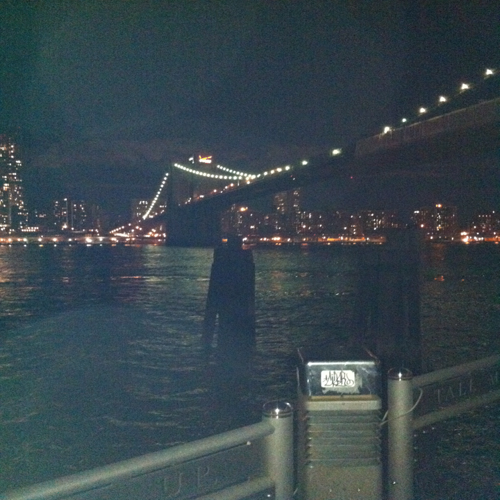What mood does this image evoke, and how does it achieve that? The image evokes a mood of tranquility and possibly contemplation. The combination of the night sky, tranquil water, and the gentle illumination of urban lights creates an atmosphere of peacefulness. It's a scene that might inspire someone to pause and reflect on the day or simply soak in the beauty of the city at night. What time of year do you think this photo was taken, and why? Considering the clear night sky and lack of snow or ice on the water, it's likely that this photo was taken in warmer months. However, without visible foliage or seasonal indicators, it's challenging to determine the specific time of year with certainty. 